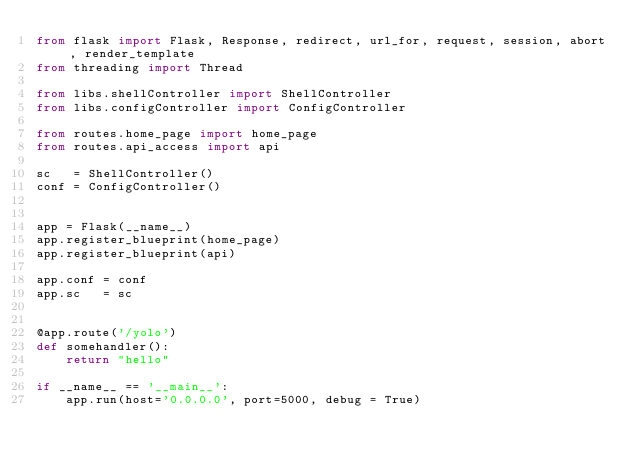Convert code to text. <code><loc_0><loc_0><loc_500><loc_500><_Python_>from flask import Flask, Response, redirect, url_for, request, session, abort, render_template
from threading import Thread

from libs.shellController import ShellController
from libs.configController import ConfigController

from routes.home_page import home_page
from routes.api_access import api

sc   = ShellController()
conf = ConfigController()


app = Flask(__name__)
app.register_blueprint(home_page)
app.register_blueprint(api)

app.conf = conf
app.sc   = sc


@app.route('/yolo')
def somehandler():
    return "hello"

if __name__ == '__main__':
    app.run(host='0.0.0.0', port=5000, debug = True) </code> 